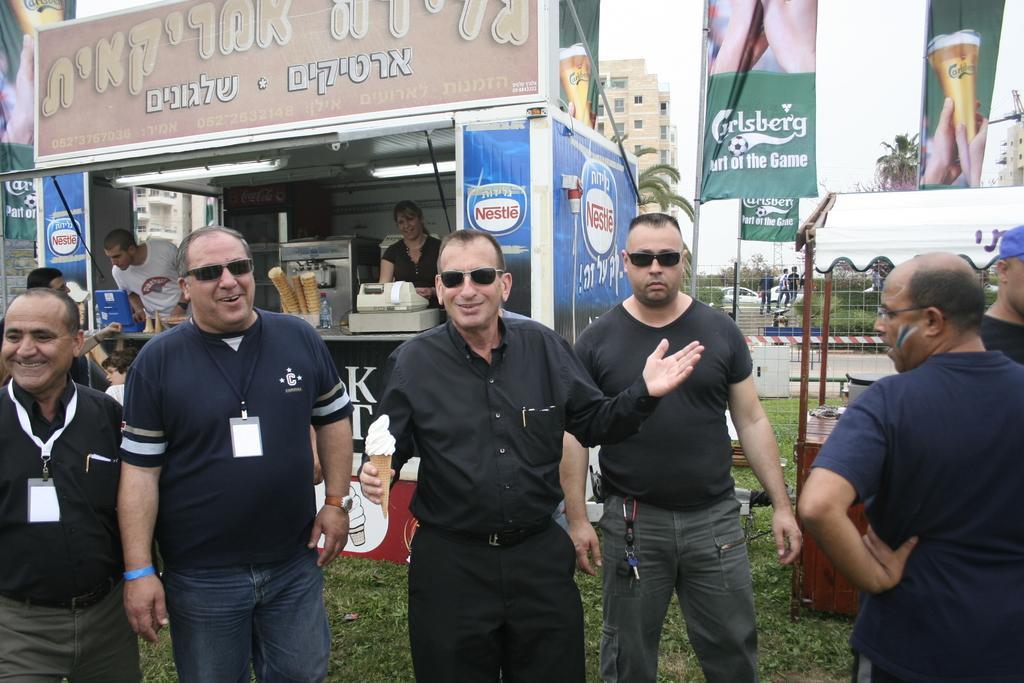Describe this image in one or two sentences. In the center of the image we can see some persons are standing, some of them are wearing goggles, id card. In the center of the image a man is standing and holding an ice-cream. In the background of the image we can see shed, some persons, coffee machine, cones, billing machine, boxes, bottle, buildings, trees, mesh, boards and some vehicles. At the bottom of the image we can see the ground. At the top of the image we can see the sky. 